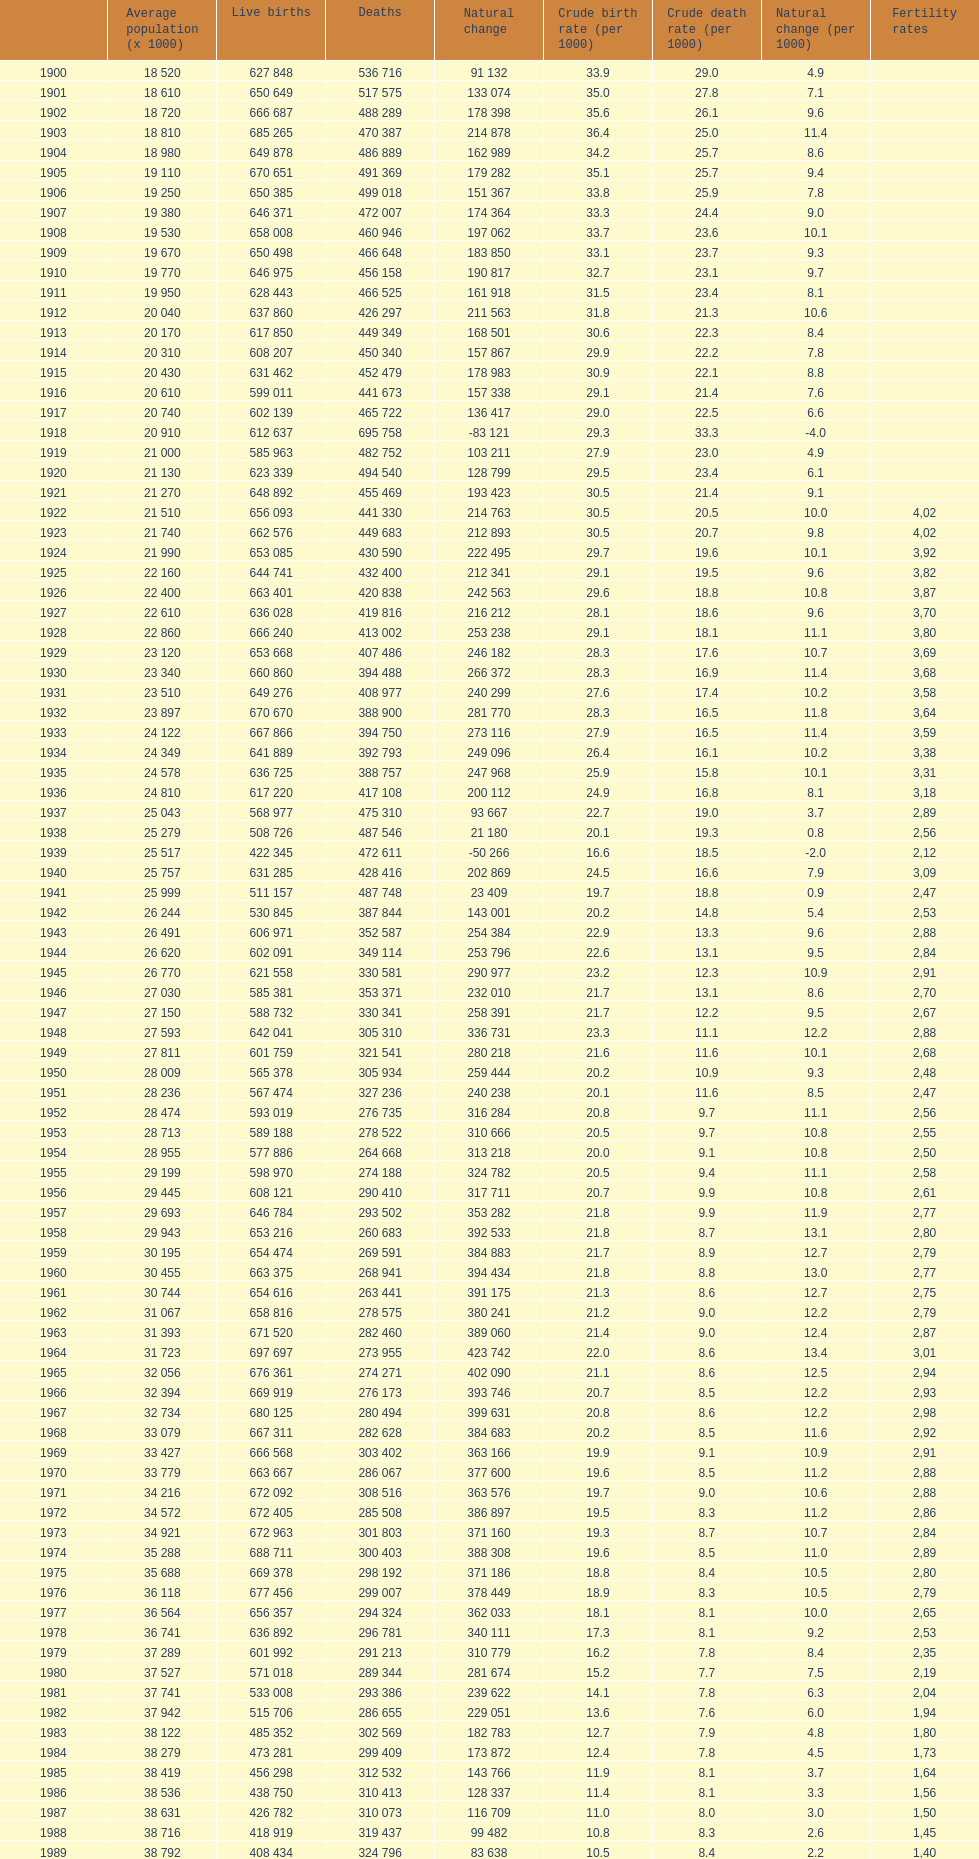Would you mind parsing the complete table? {'header': ['', 'Average population (x 1000)', 'Live births', 'Deaths', 'Natural change', 'Crude birth rate (per 1000)', 'Crude death rate (per 1000)', 'Natural change (per 1000)', 'Fertility rates'], 'rows': [['1900', '18 520', '627 848', '536 716', '91 132', '33.9', '29.0', '4.9', ''], ['1901', '18 610', '650 649', '517 575', '133 074', '35.0', '27.8', '7.1', ''], ['1902', '18 720', '666 687', '488 289', '178 398', '35.6', '26.1', '9.6', ''], ['1903', '18 810', '685 265', '470 387', '214 878', '36.4', '25.0', '11.4', ''], ['1904', '18 980', '649 878', '486 889', '162 989', '34.2', '25.7', '8.6', ''], ['1905', '19 110', '670 651', '491 369', '179 282', '35.1', '25.7', '9.4', ''], ['1906', '19 250', '650 385', '499 018', '151 367', '33.8', '25.9', '7.8', ''], ['1907', '19 380', '646 371', '472 007', '174 364', '33.3', '24.4', '9.0', ''], ['1908', '19 530', '658 008', '460 946', '197 062', '33.7', '23.6', '10.1', ''], ['1909', '19 670', '650 498', '466 648', '183 850', '33.1', '23.7', '9.3', ''], ['1910', '19 770', '646 975', '456 158', '190 817', '32.7', '23.1', '9.7', ''], ['1911', '19 950', '628 443', '466 525', '161 918', '31.5', '23.4', '8.1', ''], ['1912', '20 040', '637 860', '426 297', '211 563', '31.8', '21.3', '10.6', ''], ['1913', '20 170', '617 850', '449 349', '168 501', '30.6', '22.3', '8.4', ''], ['1914', '20 310', '608 207', '450 340', '157 867', '29.9', '22.2', '7.8', ''], ['1915', '20 430', '631 462', '452 479', '178 983', '30.9', '22.1', '8.8', ''], ['1916', '20 610', '599 011', '441 673', '157 338', '29.1', '21.4', '7.6', ''], ['1917', '20 740', '602 139', '465 722', '136 417', '29.0', '22.5', '6.6', ''], ['1918', '20 910', '612 637', '695 758', '-83 121', '29.3', '33.3', '-4.0', ''], ['1919', '21 000', '585 963', '482 752', '103 211', '27.9', '23.0', '4.9', ''], ['1920', '21 130', '623 339', '494 540', '128 799', '29.5', '23.4', '6.1', ''], ['1921', '21 270', '648 892', '455 469', '193 423', '30.5', '21.4', '9.1', ''], ['1922', '21 510', '656 093', '441 330', '214 763', '30.5', '20.5', '10.0', '4,02'], ['1923', '21 740', '662 576', '449 683', '212 893', '30.5', '20.7', '9.8', '4,02'], ['1924', '21 990', '653 085', '430 590', '222 495', '29.7', '19.6', '10.1', '3,92'], ['1925', '22 160', '644 741', '432 400', '212 341', '29.1', '19.5', '9.6', '3,82'], ['1926', '22 400', '663 401', '420 838', '242 563', '29.6', '18.8', '10.8', '3,87'], ['1927', '22 610', '636 028', '419 816', '216 212', '28.1', '18.6', '9.6', '3,70'], ['1928', '22 860', '666 240', '413 002', '253 238', '29.1', '18.1', '11.1', '3,80'], ['1929', '23 120', '653 668', '407 486', '246 182', '28.3', '17.6', '10.7', '3,69'], ['1930', '23 340', '660 860', '394 488', '266 372', '28.3', '16.9', '11.4', '3,68'], ['1931', '23 510', '649 276', '408 977', '240 299', '27.6', '17.4', '10.2', '3,58'], ['1932', '23 897', '670 670', '388 900', '281 770', '28.3', '16.5', '11.8', '3,64'], ['1933', '24 122', '667 866', '394 750', '273 116', '27.9', '16.5', '11.4', '3,59'], ['1934', '24 349', '641 889', '392 793', '249 096', '26.4', '16.1', '10.2', '3,38'], ['1935', '24 578', '636 725', '388 757', '247 968', '25.9', '15.8', '10.1', '3,31'], ['1936', '24 810', '617 220', '417 108', '200 112', '24.9', '16.8', '8.1', '3,18'], ['1937', '25 043', '568 977', '475 310', '93 667', '22.7', '19.0', '3.7', '2,89'], ['1938', '25 279', '508 726', '487 546', '21 180', '20.1', '19.3', '0.8', '2,56'], ['1939', '25 517', '422 345', '472 611', '-50 266', '16.6', '18.5', '-2.0', '2,12'], ['1940', '25 757', '631 285', '428 416', '202 869', '24.5', '16.6', '7.9', '3,09'], ['1941', '25 999', '511 157', '487 748', '23 409', '19.7', '18.8', '0.9', '2,47'], ['1942', '26 244', '530 845', '387 844', '143 001', '20.2', '14.8', '5.4', '2,53'], ['1943', '26 491', '606 971', '352 587', '254 384', '22.9', '13.3', '9.6', '2,88'], ['1944', '26 620', '602 091', '349 114', '253 796', '22.6', '13.1', '9.5', '2,84'], ['1945', '26 770', '621 558', '330 581', '290 977', '23.2', '12.3', '10.9', '2,91'], ['1946', '27 030', '585 381', '353 371', '232 010', '21.7', '13.1', '8.6', '2,70'], ['1947', '27 150', '588 732', '330 341', '258 391', '21.7', '12.2', '9.5', '2,67'], ['1948', '27 593', '642 041', '305 310', '336 731', '23.3', '11.1', '12.2', '2,88'], ['1949', '27 811', '601 759', '321 541', '280 218', '21.6', '11.6', '10.1', '2,68'], ['1950', '28 009', '565 378', '305 934', '259 444', '20.2', '10.9', '9.3', '2,48'], ['1951', '28 236', '567 474', '327 236', '240 238', '20.1', '11.6', '8.5', '2,47'], ['1952', '28 474', '593 019', '276 735', '316 284', '20.8', '9.7', '11.1', '2,56'], ['1953', '28 713', '589 188', '278 522', '310 666', '20.5', '9.7', '10.8', '2,55'], ['1954', '28 955', '577 886', '264 668', '313 218', '20.0', '9.1', '10.8', '2,50'], ['1955', '29 199', '598 970', '274 188', '324 782', '20.5', '9.4', '11.1', '2,58'], ['1956', '29 445', '608 121', '290 410', '317 711', '20.7', '9.9', '10.8', '2,61'], ['1957', '29 693', '646 784', '293 502', '353 282', '21.8', '9.9', '11.9', '2,77'], ['1958', '29 943', '653 216', '260 683', '392 533', '21.8', '8.7', '13.1', '2,80'], ['1959', '30 195', '654 474', '269 591', '384 883', '21.7', '8.9', '12.7', '2,79'], ['1960', '30 455', '663 375', '268 941', '394 434', '21.8', '8.8', '13.0', '2,77'], ['1961', '30 744', '654 616', '263 441', '391 175', '21.3', '8.6', '12.7', '2,75'], ['1962', '31 067', '658 816', '278 575', '380 241', '21.2', '9.0', '12.2', '2,79'], ['1963', '31 393', '671 520', '282 460', '389 060', '21.4', '9.0', '12.4', '2,87'], ['1964', '31 723', '697 697', '273 955', '423 742', '22.0', '8.6', '13.4', '3,01'], ['1965', '32 056', '676 361', '274 271', '402 090', '21.1', '8.6', '12.5', '2,94'], ['1966', '32 394', '669 919', '276 173', '393 746', '20.7', '8.5', '12.2', '2,93'], ['1967', '32 734', '680 125', '280 494', '399 631', '20.8', '8.6', '12.2', '2,98'], ['1968', '33 079', '667 311', '282 628', '384 683', '20.2', '8.5', '11.6', '2,92'], ['1969', '33 427', '666 568', '303 402', '363 166', '19.9', '9.1', '10.9', '2,91'], ['1970', '33 779', '663 667', '286 067', '377 600', '19.6', '8.5', '11.2', '2,88'], ['1971', '34 216', '672 092', '308 516', '363 576', '19.7', '9.0', '10.6', '2,88'], ['1972', '34 572', '672 405', '285 508', '386 897', '19.5', '8.3', '11.2', '2,86'], ['1973', '34 921', '672 963', '301 803', '371 160', '19.3', '8.7', '10.7', '2,84'], ['1974', '35 288', '688 711', '300 403', '388 308', '19.6', '8.5', '11.0', '2,89'], ['1975', '35 688', '669 378', '298 192', '371 186', '18.8', '8.4', '10.5', '2,80'], ['1976', '36 118', '677 456', '299 007', '378 449', '18.9', '8.3', '10.5', '2,79'], ['1977', '36 564', '656 357', '294 324', '362 033', '18.1', '8.1', '10.0', '2,65'], ['1978', '36 741', '636 892', '296 781', '340 111', '17.3', '8.1', '9.2', '2,53'], ['1979', '37 289', '601 992', '291 213', '310 779', '16.2', '7.8', '8.4', '2,35'], ['1980', '37 527', '571 018', '289 344', '281 674', '15.2', '7.7', '7.5', '2,19'], ['1981', '37 741', '533 008', '293 386', '239 622', '14.1', '7.8', '6.3', '2,04'], ['1982', '37 942', '515 706', '286 655', '229 051', '13.6', '7.6', '6.0', '1,94'], ['1983', '38 122', '485 352', '302 569', '182 783', '12.7', '7.9', '4.8', '1,80'], ['1984', '38 279', '473 281', '299 409', '173 872', '12.4', '7.8', '4.5', '1,73'], ['1985', '38 419', '456 298', '312 532', '143 766', '11.9', '8.1', '3.7', '1,64'], ['1986', '38 536', '438 750', '310 413', '128 337', '11.4', '8.1', '3.3', '1,56'], ['1987', '38 631', '426 782', '310 073', '116 709', '11.0', '8.0', '3.0', '1,50'], ['1988', '38 716', '418 919', '319 437', '99 482', '10.8', '8.3', '2.6', '1,45'], ['1989', '38 792', '408 434', '324 796', '83 638', '10.5', '8.4', '2.2', '1,40'], ['1990', '38 851', '401 425', '333 142', '68 283', '10.3', '8.6', '1.8', '1,36'], ['1991', '38 940', '395 989', '337 691', '58 298', '10.2', '8.7', '1.5', '1,33'], ['1992', '39 068', '396 747', '331 515', '65 232', '10.2', '8.5', '1.7', '1,32'], ['1993', '39 190', '385 786', '339 661', '46 125', '9.8', '8.7', '1.2', '1,26'], ['1994', '39 295', '370 148', '338 242', '31 906', '9.4', '8.6', '0.8', '1,21'], ['1995', '39 387', '363 469', '346 227', '17 242', '9.2', '8.8', '0.4', '1,18'], ['1996', '39 478', '362 626', '351 449', '11 177', '9.2', '8.9', '0.3', '1,17'], ['1997', '39 582', '369 035', '349 521', '19 514', '9.3', '8.8', '0.5', '1,19'], ['1998', '39 721', '365 193', '360 511', '4 682', '9.2', '9.1', '0.1', '1,15'], ['1999', '39 927', '380 130', '371 102', '9 028', '9.5', '9.3', '0.2', '1,20'], ['2000', '40 264', '397 632', '360 391', '37 241', '9.9', '9.0', '0.9', '1,23'], ['2001', '40 476', '406 380', '360 131', '46 249', '10.0', '8.8', '1.1', '1,24'], ['2002', '41 035', '418 846', '368 618', '50 228', '10.1', '8.9', '1.2', '1,26'], ['2003', '41 827', '441 881', '384 828', '57 053', '10.5', '9.2', '1.4', '1,31'], ['2004', '42 547', '454 591', '371 934', '82 657', '10.6', '8.7', '1.9', '1,33'], ['2005', '43 296', '466 371', '387 355', '79 016', '10.7', '8.9', '1.8', '1,35'], ['2006', '44 009', '482 957', '371 478', '111 479', '10.9', '8.4', '2.5', '1,36'], ['2007', '44 784', '492 527', '385 361', '107 166', '10.9', '8.5', '2.4', '1,40'], ['2008', '45 668', '518 503', '384 198', '134 305', '11.4', '8.4', '3.0', '1,46'], ['2009', '46 239', '493 717', '383 209', '110 508', '10.7', '8.2', '2.5', '1,39'], ['2010', '46 486', '485 252', '380 234', '105 218', '10.5', '8.2', '2.3', '1.38'], ['2011', '46 667', '470 553', '386 017', '84 536', '10.2', '8.4', '1.8', '1.34'], ['2012', '46 818', '454 648', '402 950', '51 698', '9.7', '8.6', '1.1', '1.32'], ['2013', '', '', '', '', '', '', '', '1.29']]} In which year did spain display the maximum number of live births exceeding deaths? 1964. 